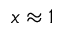Convert formula to latex. <formula><loc_0><loc_0><loc_500><loc_500>x \approx 1</formula> 